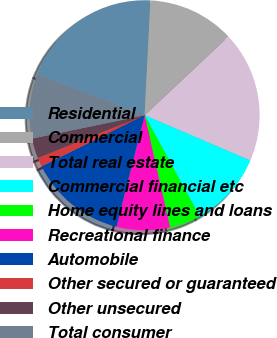Convert chart to OTSL. <chart><loc_0><loc_0><loc_500><loc_500><pie_chart><fcel>Residential<fcel>Commercial<fcel>Total real estate<fcel>Commercial financial etc<fcel>Home equity lines and loans<fcel>Recreational finance<fcel>Automobile<fcel>Other secured or guaranteed<fcel>Other unsecured<fcel>Total consumer<nl><fcel>20.0%<fcel>12.19%<fcel>18.44%<fcel>10.62%<fcel>4.38%<fcel>7.5%<fcel>13.75%<fcel>1.25%<fcel>2.81%<fcel>9.06%<nl></chart> 